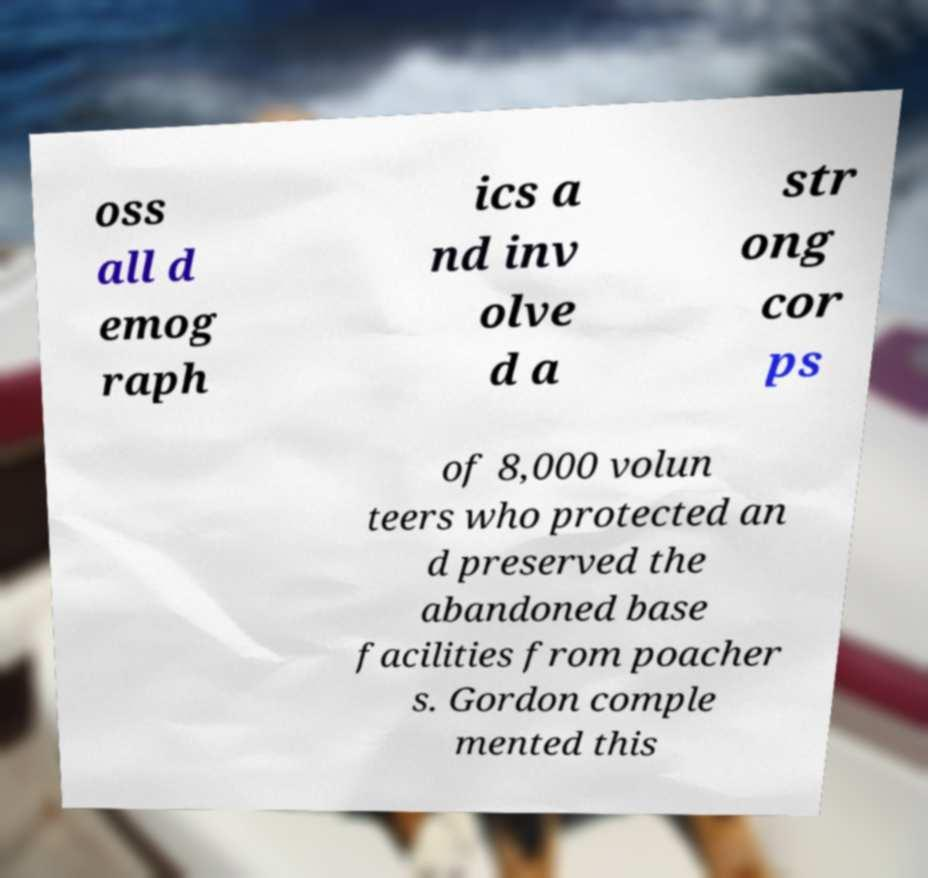Please identify and transcribe the text found in this image. oss all d emog raph ics a nd inv olve d a str ong cor ps of 8,000 volun teers who protected an d preserved the abandoned base facilities from poacher s. Gordon comple mented this 